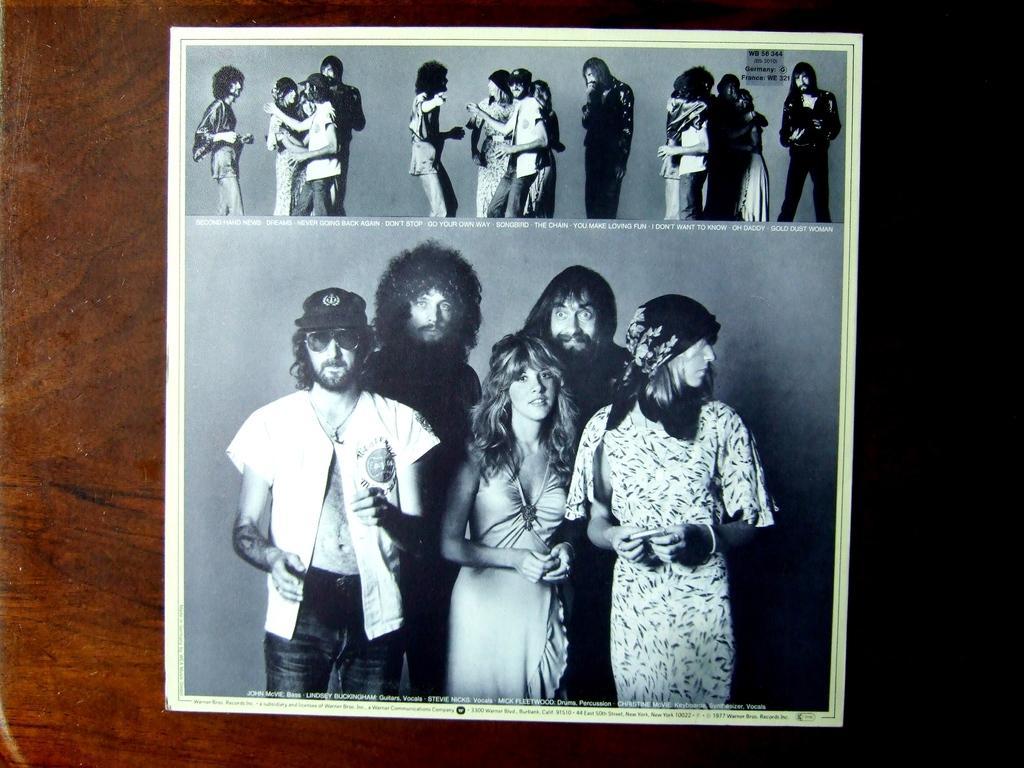Describe this image in one or two sentences. In this image we can see a photograph pasted on the wooden wall. In the photograph we can see people standing and there is text. 